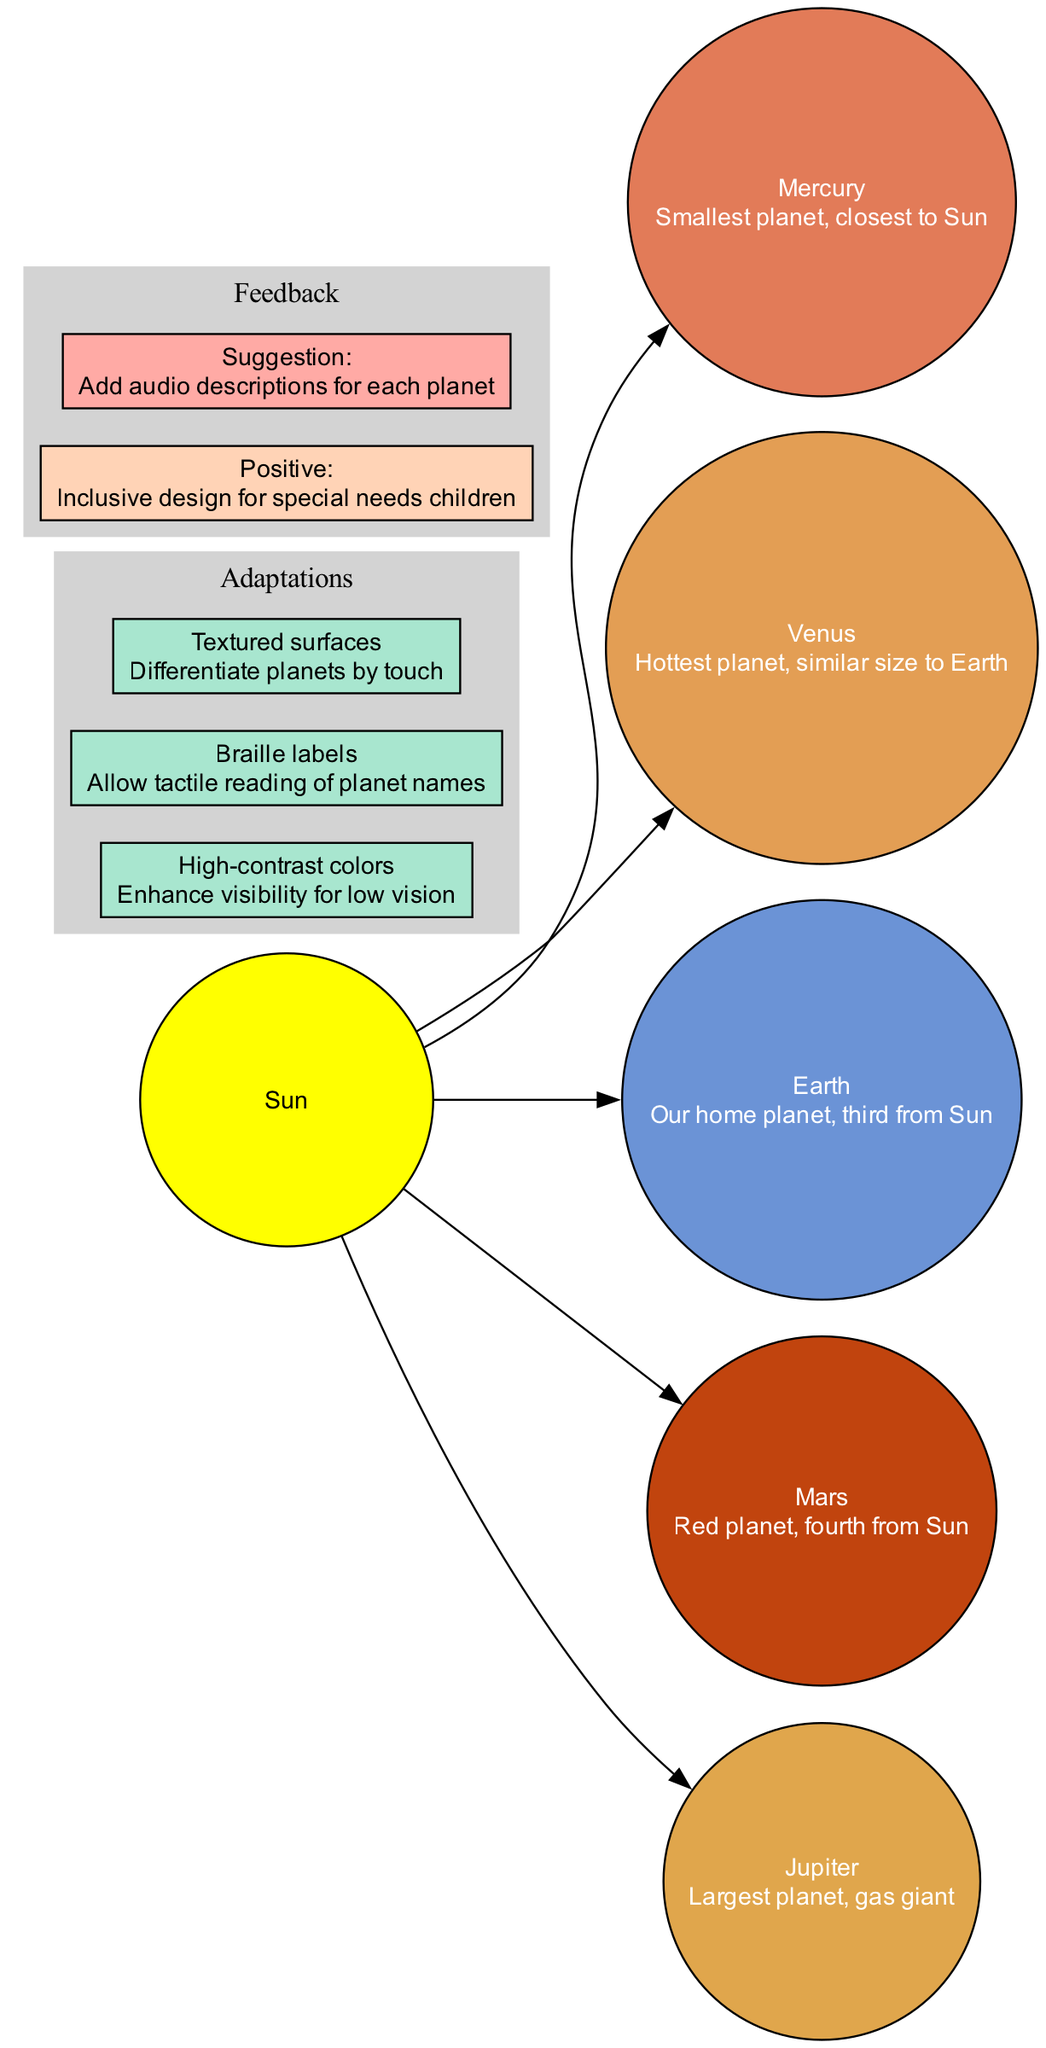What is at the center of the solar system diagram? The diagram indicates that the Sun is at the center, as it is the first node added and all the planets link to it.
Answer: Sun How many planets are shown in the diagram? The diagram lists five planets around the Sun, each represented by a separate node connected to the Sun.
Answer: 5 What color represents Jupiter in the diagram? Jupiter is depicted using a specific color, identified within the list of high-contrast colors assigned to each planet. It corresponds to the largest planet, which is the fifth one.
Answer: #E0A64C Which planet is described as the “Red planet”? The diagram has a description associated with Mars that explicitly states it is the "Red planet." This description helps in identifying the correct planet.
Answer: Mars What adaptation is used to enhance visibility for low vision? The adaptations section lists features, and high-contrast colors is clearly mentioned as a feature aimed at enhancing visibility specifically for individuals with low vision.
Answer: High-contrast colors Which adaptation allows tactile reading of planet names? Among the adaptations, Braille labels are specified as a feature that facilitates tactile reading, thereby addressing the needs of individuals with visual impairments.
Answer: Braille labels How many adaptations are listed in the diagram? The adaptations section contains three distinct features mentioned, and each is clearly outlined with its respective purpose.
Answer: 3 What is the positive feedback given about the diagram? The feedback section indicates that the inclusive design for special needs children is considered the positive aspect of the diagram, emphasizing its usability for that group.
Answer: Inclusive design for special needs children What suggestion is made for further improvement in the diagram? The feedback includes a suggestion to add audio descriptions for each planet, highlighting an additional way to enhance accessibility and provide information to users.
Answer: Add audio descriptions for each planet 